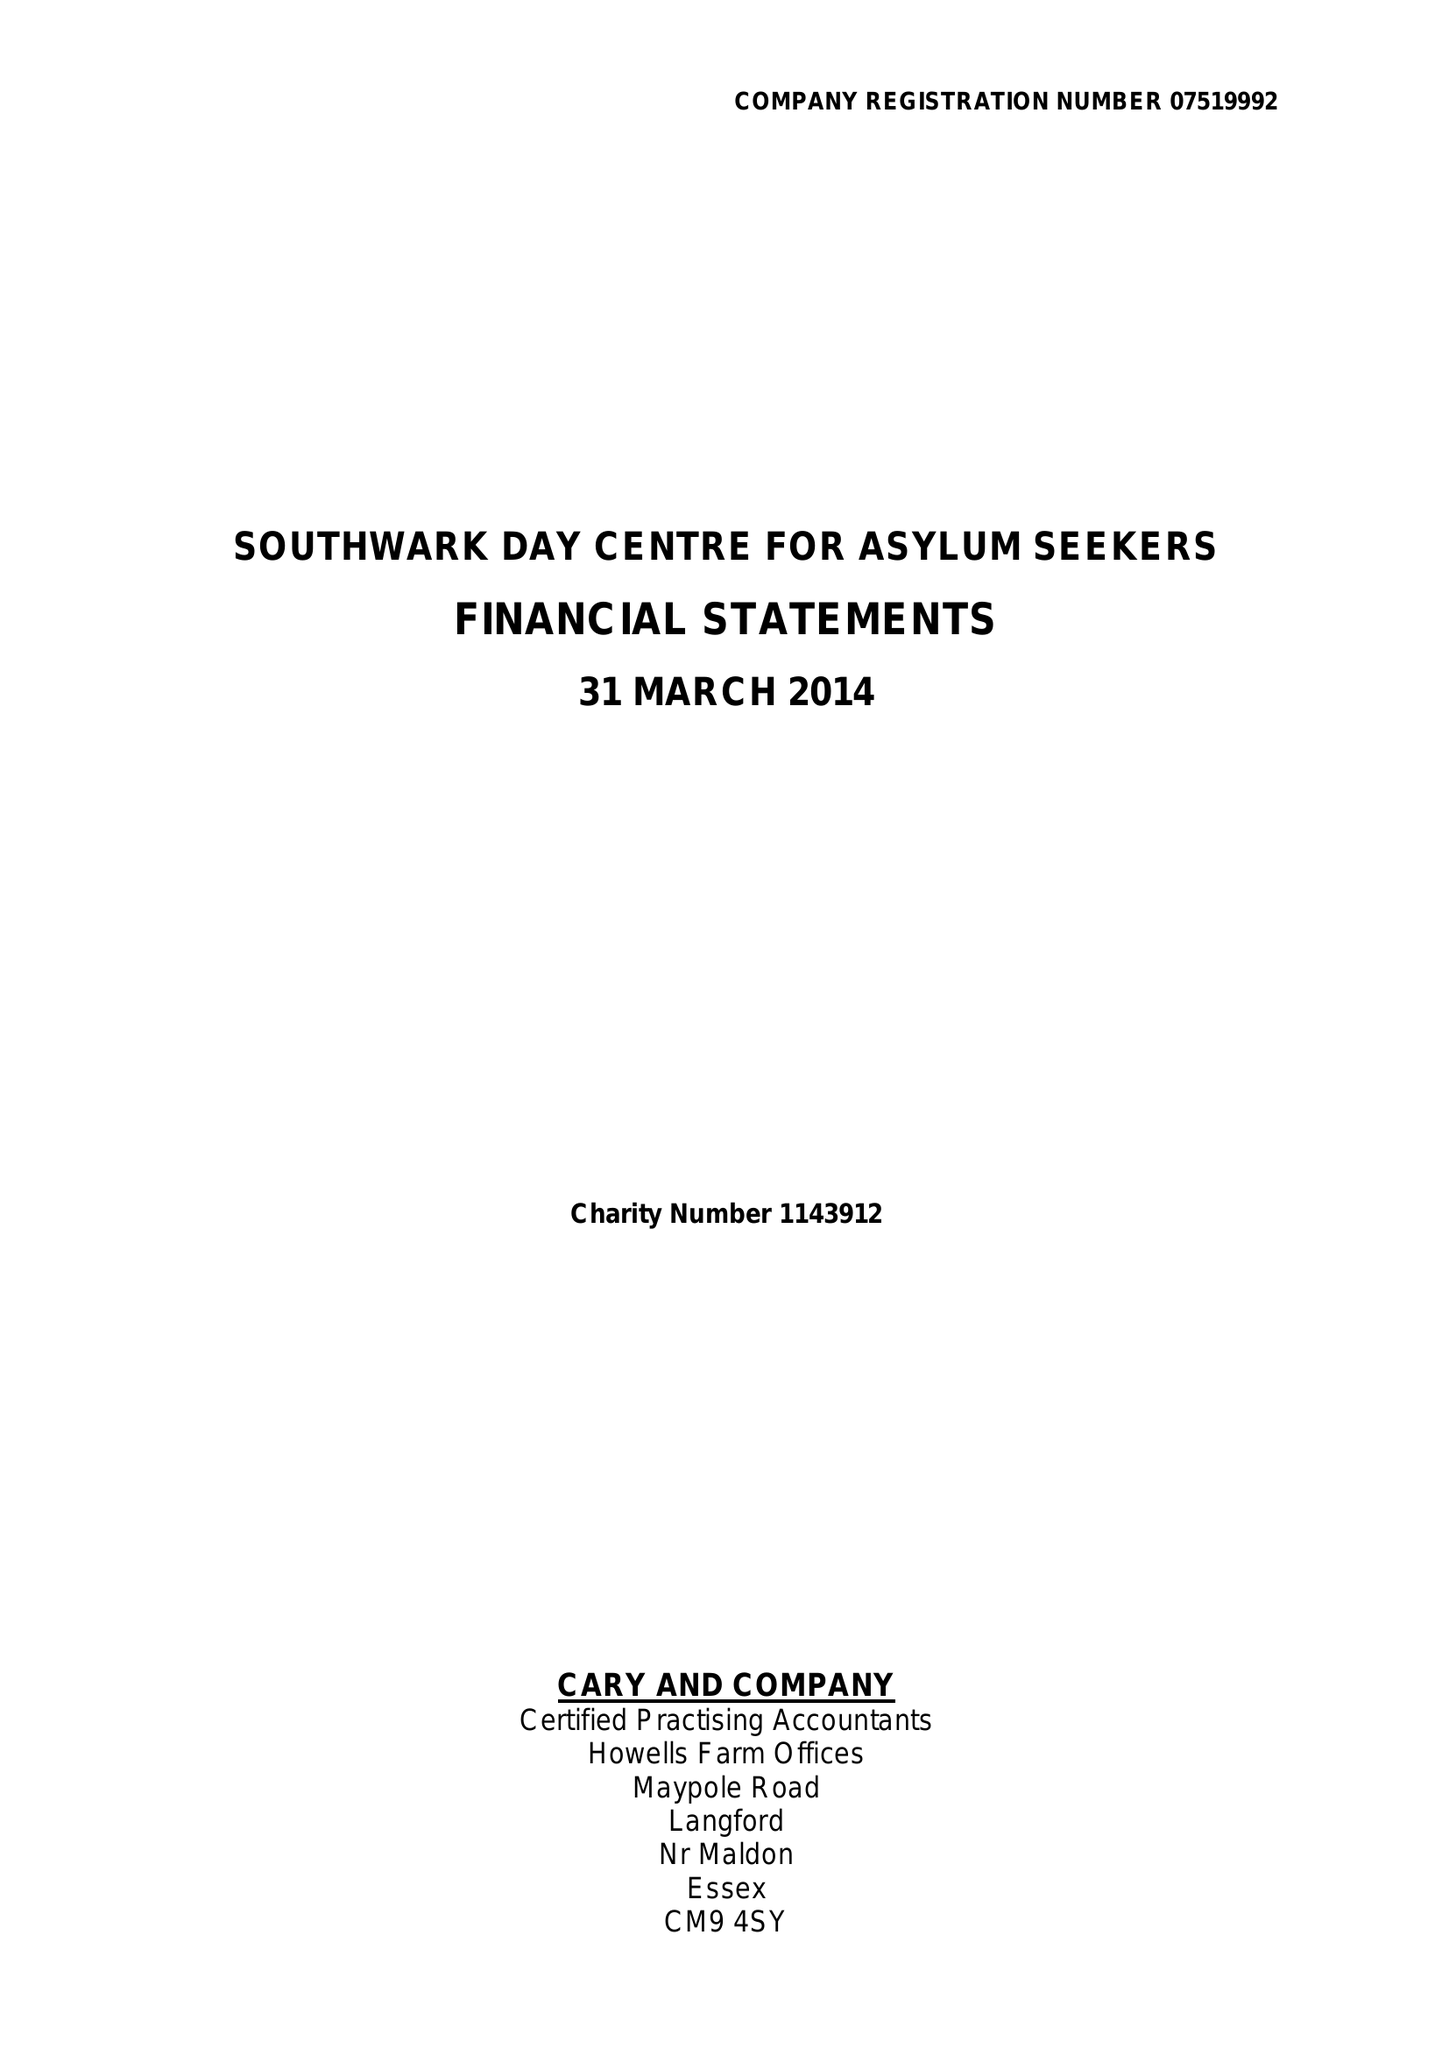What is the value for the address__street_line?
Answer the question using a single word or phrase. COPLESTON ROAD 